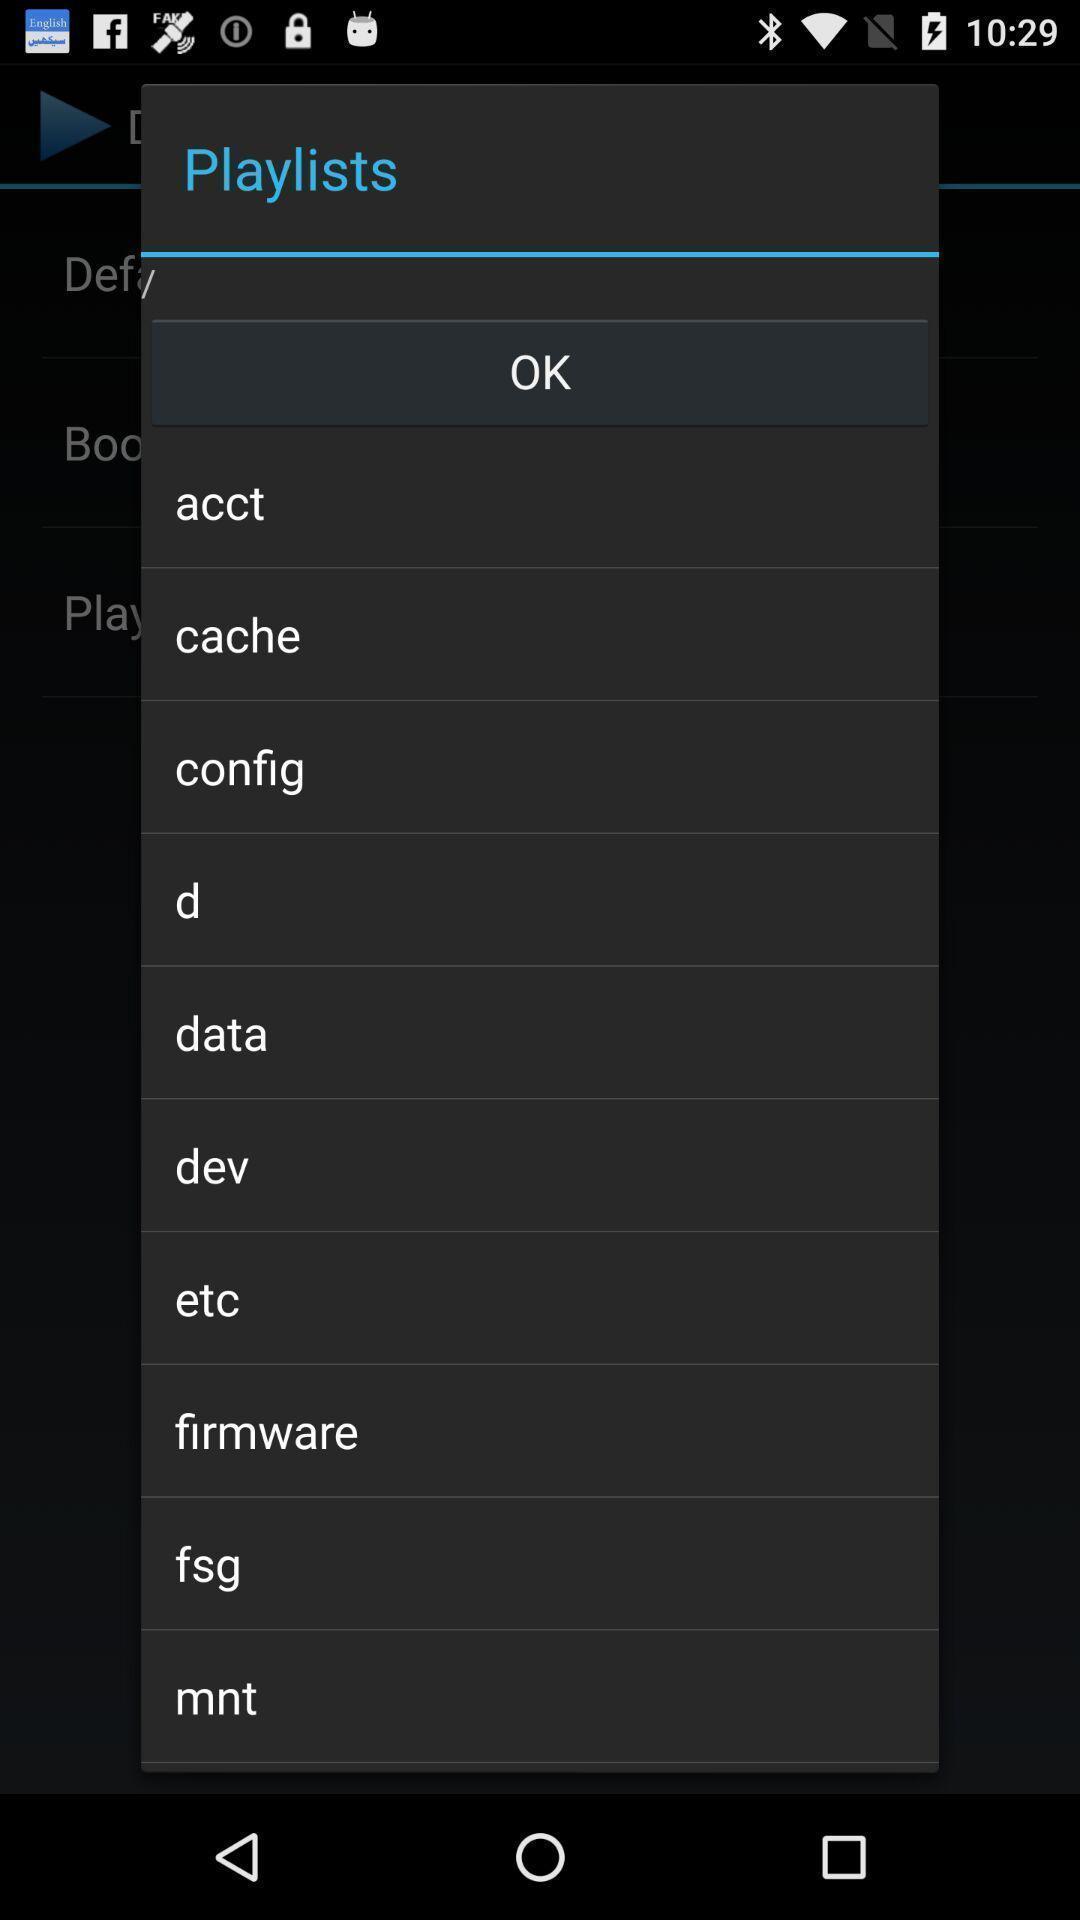Describe this image in words. Pop-up to select the option from playlists. 